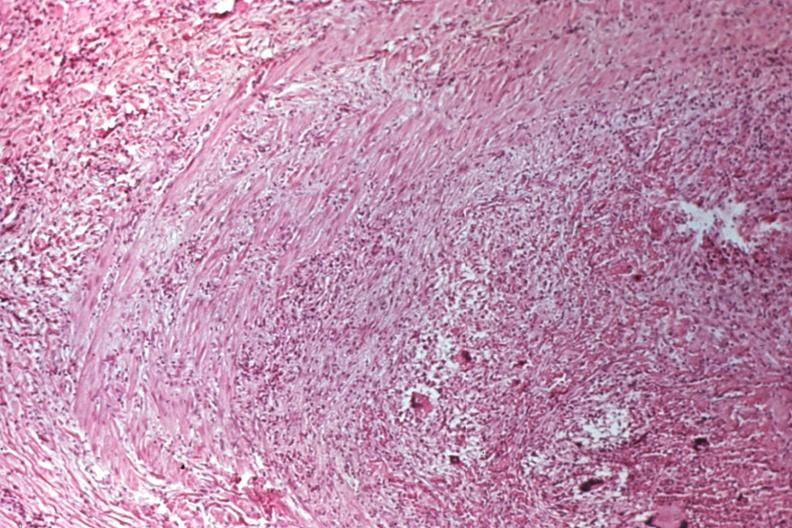where is this?
Answer the question using a single word or phrase. Skin 